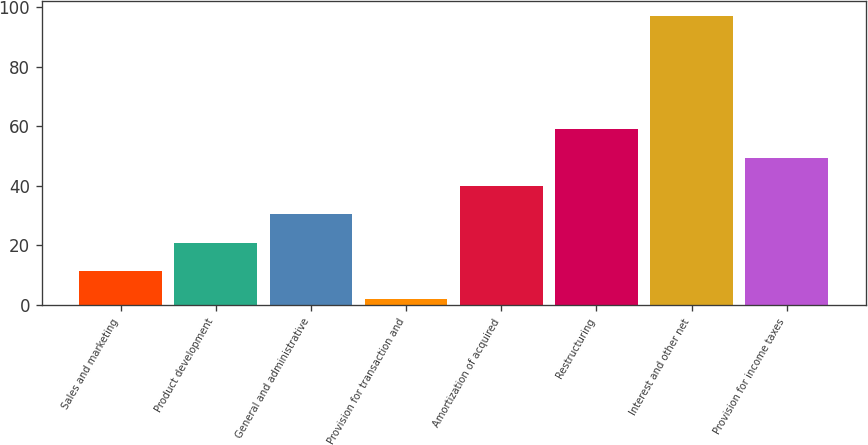<chart> <loc_0><loc_0><loc_500><loc_500><bar_chart><fcel>Sales and marketing<fcel>Product development<fcel>General and administrative<fcel>Provision for transaction and<fcel>Amortization of acquired<fcel>Restructuring<fcel>Interest and other net<fcel>Provision for income taxes<nl><fcel>11.5<fcel>21<fcel>30.5<fcel>2<fcel>40<fcel>59<fcel>97<fcel>49.5<nl></chart> 